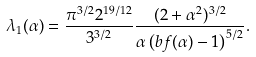<formula> <loc_0><loc_0><loc_500><loc_500>\lambda _ { 1 } ( \alpha ) = \frac { \pi ^ { 3 / 2 } 2 ^ { 1 9 / 1 2 } } { 3 ^ { 3 / 2 } } \frac { ( 2 + \alpha ^ { 2 } ) ^ { 3 / 2 } } { \alpha \left ( b f ( \alpha ) - 1 \right ) ^ { 5 / 2 } } .</formula> 